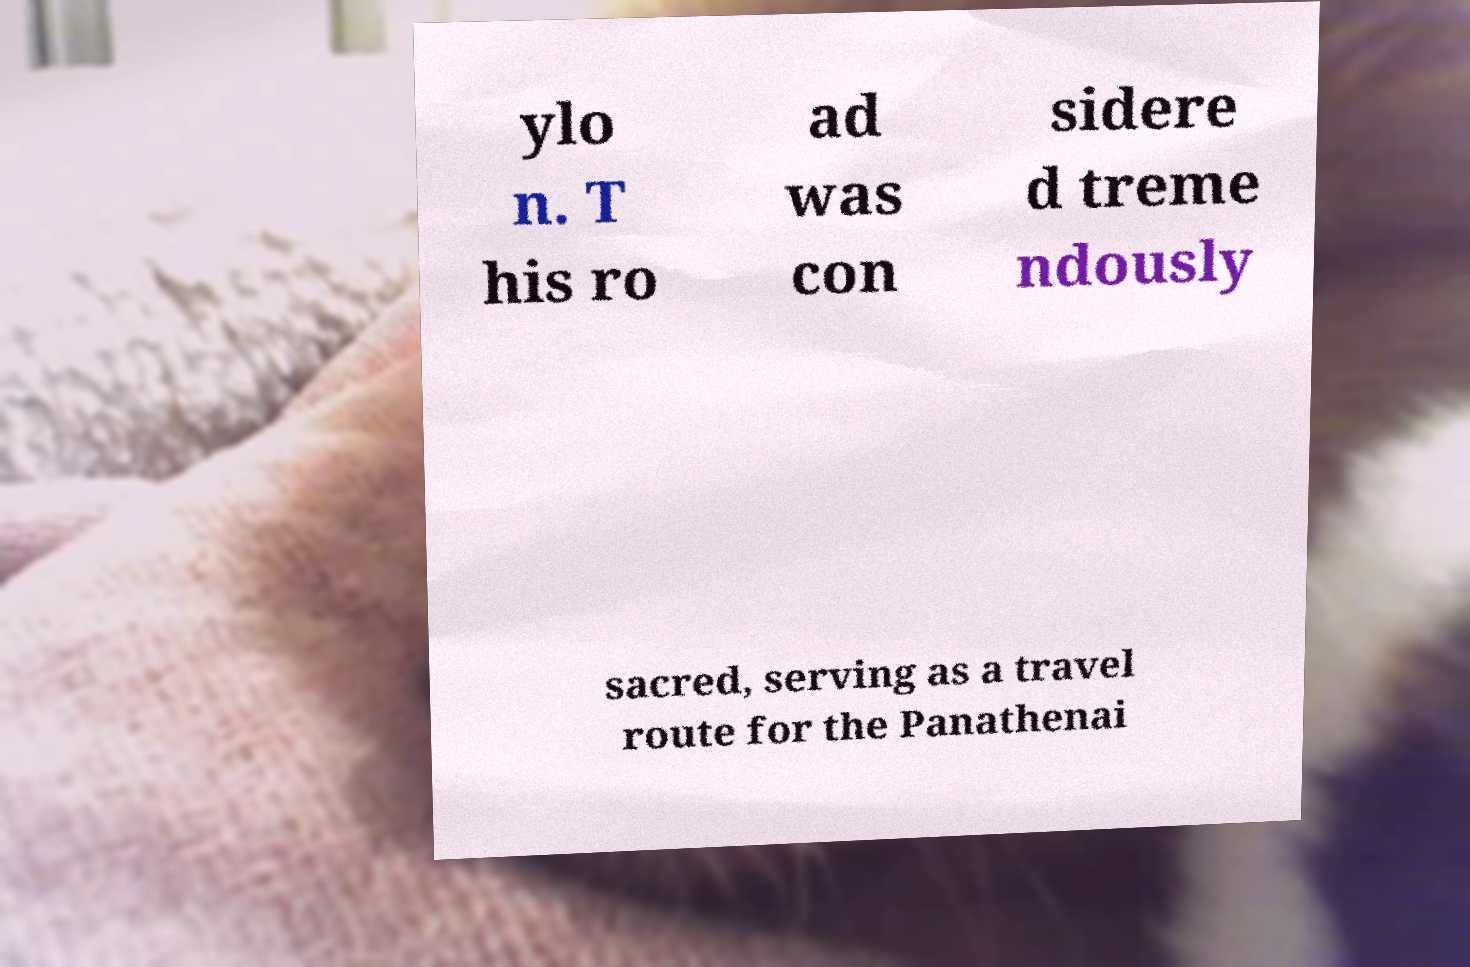Please read and relay the text visible in this image. What does it say? ylo n. T his ro ad was con sidere d treme ndously sacred, serving as a travel route for the Panathenai 